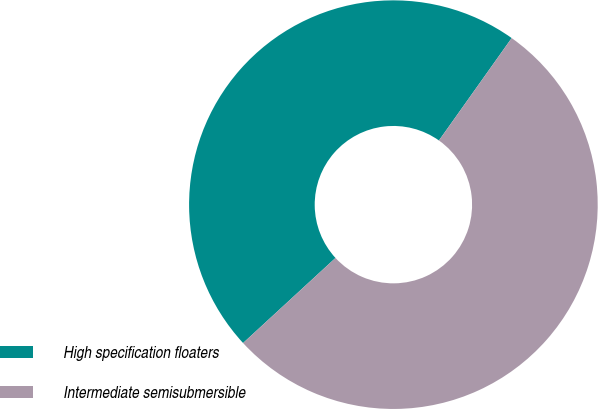Convert chart to OTSL. <chart><loc_0><loc_0><loc_500><loc_500><pie_chart><fcel>High specification floaters<fcel>Intermediate semisubmersible<nl><fcel>46.67%<fcel>53.33%<nl></chart> 